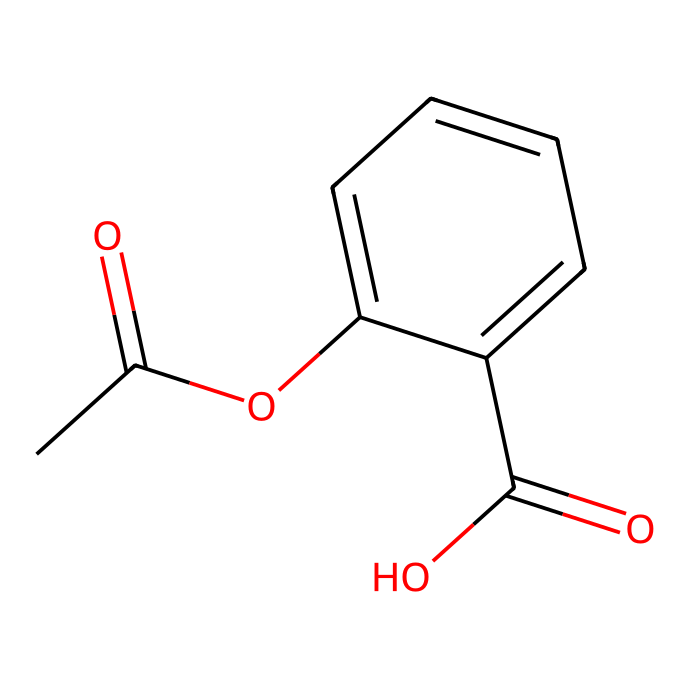What is the IUPAC name of this compound? The SMILES representation indicates the structure composed of an acetyl group (CC(=O)) and a carboxylic acid group (C(=O)O) attached to a benzene ring with an ester linkage (-OC). This corresponds to the IUPAC name "2-acetoxybenzoic acid," commonly known as aspirin.
Answer: 2-acetoxybenzoic acid How many carbon atoms are present in this structure? By analyzing the SMILES, we count the number of 'C' characters in the representation. There are 9 carbon atoms represented.
Answer: 9 What functional groups are present in this chemical? The SMILES shows an ester group (CC(=O)O) and a carboxylic acid group (C(=O)O). Therefore, the functional groups present are an ester and a carboxylic acid.
Answer: ester, carboxylic acid How many double bonds are found in this compound? In the SMILES, the '=' denotes the presence of double bonds. There are three double bonds identified: one in the acetyl group, one in the carboxylic acid, and one in the benzene ring.
Answer: 3 Is this compound a non-electrolyte? Aspirin does not dissociate into ions in solution, making it a non-electrolyte. Non-electrolytes typically include organic compounds that do not conduct electricity in their dissolved form.
Answer: yes Which part of the structure contributes to its pain-relieving properties? The acetyl group (CC(=O)) is responsible for aspirin's analgesic properties, as it inhibits cyclooxygenase enzymes and reduces the synthesis of prostaglandins involved in pain signaling.
Answer: acetyl group 